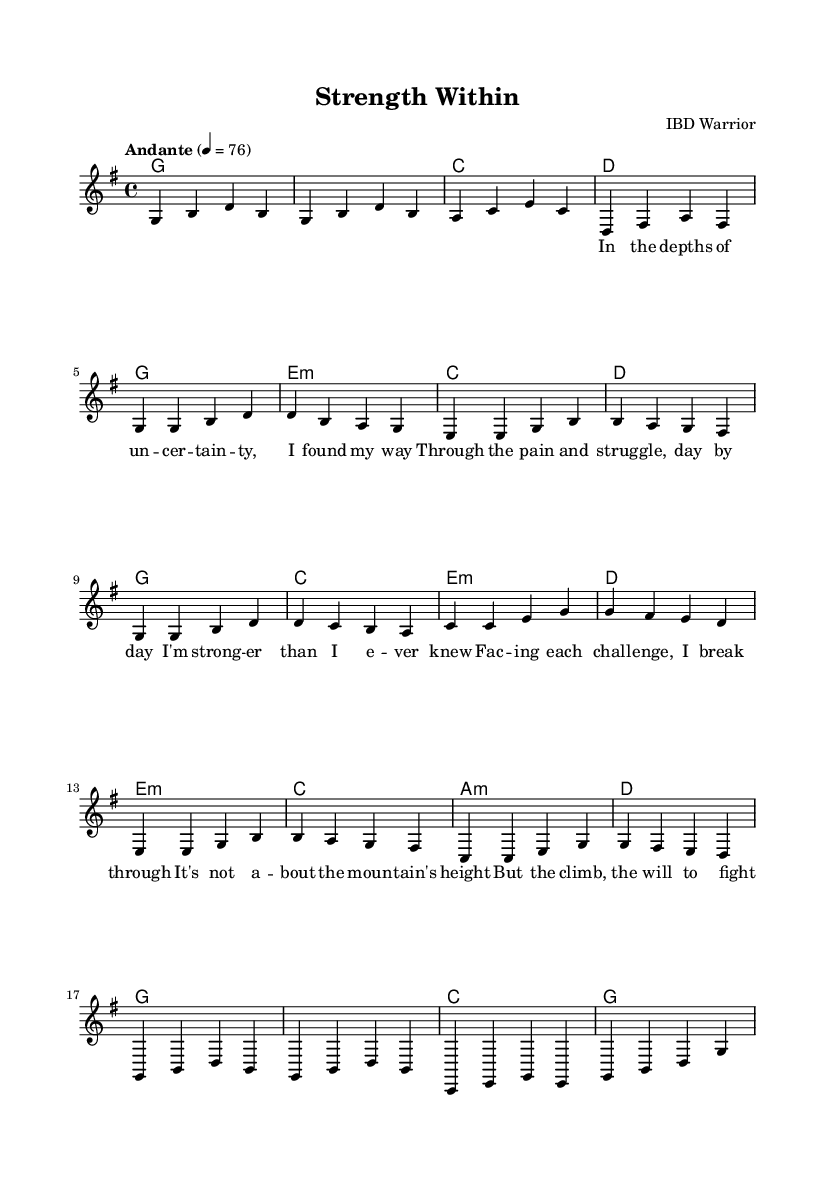What is the key signature of this music? The key signature of the music is G major, which has one sharp (F#). This can be inferred from the key signature indicated at the beginning of the score.
Answer: G major What is the time signature of this piece? The time signature is 4/4, as shown at the beginning of the score. This means there are four beats in each measure and the quarter note gets one beat.
Answer: 4/4 What is the tempo marking given in the score? The tempo marking is "Andante," which indicates a moderate pace of a walking speed. This is typically represented by the metronome marking, which is specified as beats per minute.
Answer: Andante How many measures are there in the melody section? The melody section consists of 16 measures. By counting the grouping of notes and bars in the melody line, we can determine the total number of measures.
Answer: 16 What is the first chord of the song? The first chord indicated in the score is G major, which is shown in the harmony section at the beginning of the piece. It is the chord played at the start of the melody.
Answer: G In which section does the chorus begin? The chorus begins after the first verse, which can be identified by the specific lyrics provided and the structure of the song where the phrase "I'm stronger than I ever knew" appears, indicating the transition from the verse to the chorus.
Answer: Chorus What is the mood conveyed by this piece of music? The mood of the music is romantic and uplifting, as indicated by the lyrical content about overcoming challenges and the soft acoustic guitar style characteristic of gentle ballads, which evokes emotions of hope and resilience.
Answer: Uplifting 